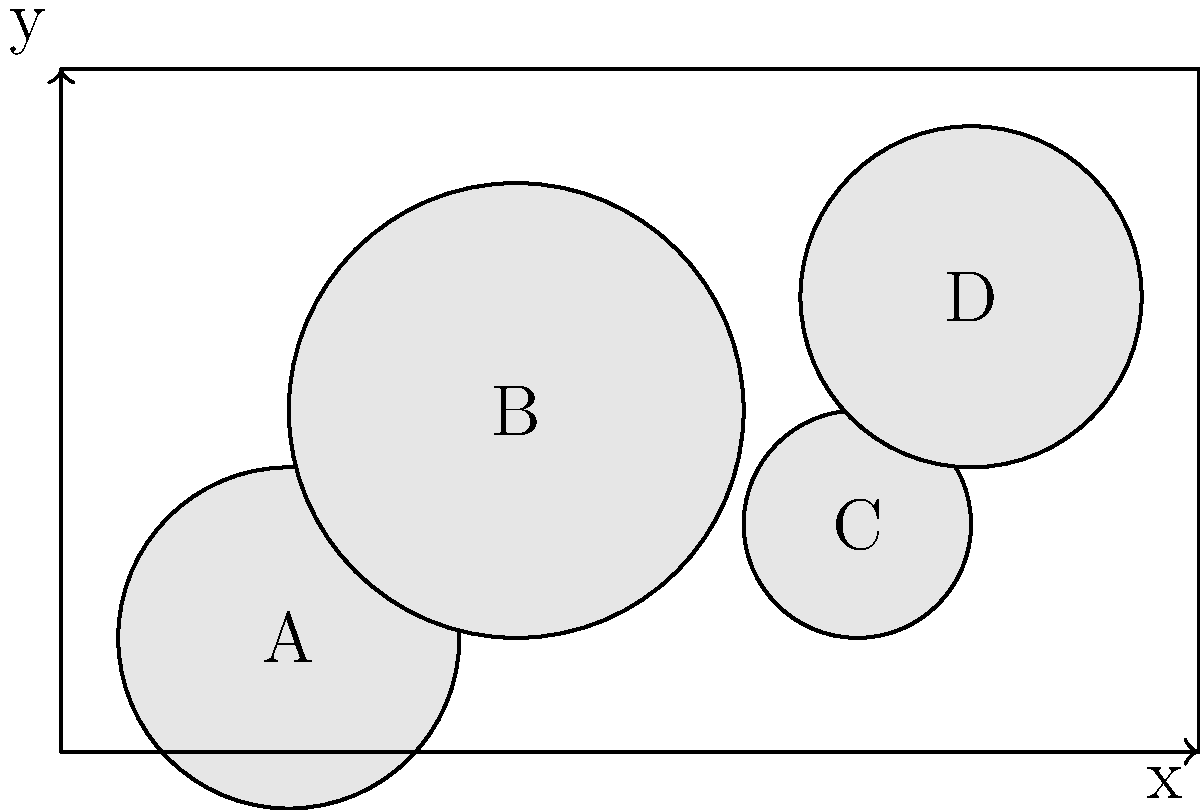In the given diorama space of $10 \times 6$ units, four miniature objects (A, B, C, and D) are placed as shown. To optimize the placement and create more space, you need to move one object. Which object should be moved, and where should it be placed to maximize the minimum distance between any two objects while keeping all objects within the diorama? To optimize the placement of miniature objects in the diorama, we need to follow these steps:

1. Calculate the current minimum distance between objects:
   - Distance AB: $\sqrt{(4-2)^2 + (3-1)^2} = \sqrt{8} \approx 2.83$
   - Distance AC: $\sqrt{(7-2)^2 + (2-1)^2} = \sqrt{26} \approx 5.10$
   - Distance AD: $\sqrt{(8-2)^2 + (4-1)^2} = \sqrt{45} \approx 6.71$
   - Distance BC: $\sqrt{(7-4)^2 + (2-3)^2} = \sqrt{10} \approx 3.16$
   - Distance BD: $\sqrt{(8-4)^2 + (4-3)^2} = \sqrt{17} \approx 4.12$
   - Distance CD: $\sqrt{(8-7)^2 + (4-2)^2} = \sqrt{5} \approx 2.24$

   The current minimum distance is between C and D (2.24 units).

2. Identify the object to move:
   Object C is involved in the shortest distance and is closest to the edge, making it the best candidate to move.

3. Determine the optimal new position:
   To maximize the minimum distance, we should move C to the opposite corner from the cluster of other objects. The optimal position would be near (1, 5).

4. Verify the new minimum distances:
   - New AC: $\sqrt{(1-2)^2 + (5-1)^2} = \sqrt{17} \approx 4.12$
   - New BC: $\sqrt{(1-4)^2 + (5-3)^2} = \sqrt{13} \approx 3.61$
   - New CD: $\sqrt{(1-8)^2 + (5-4)^2} = \sqrt{50} \approx 7.07$

   The new minimum distance is between B and C (3.61 units), which is larger than the original minimum distance.

5. Ensure the new position is within the diorama:
   The position (1, 5) is within the $10 \times 6$ diorama space.
Answer: Move object C to (1, 5) 